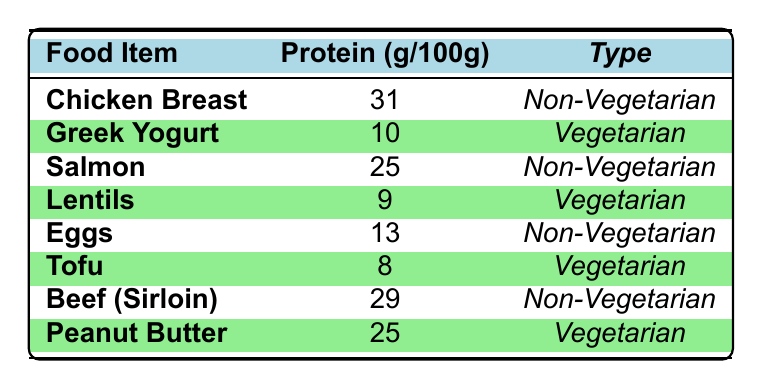What is the protein content of Chicken Breast? The protein content of Chicken Breast can be found in the table, where it is listed as 31 g per 100 g.
Answer: 31 g Which vegetarian food item has the highest protein content? In the table, the protein contents of vegetarian foods are listed. Greek Yogurt has the highest amount at 10 g per 100 g.
Answer: Greek Yogurt What is the protein difference between Beef (Sirloin) and Eggs? According to the table, Beef (Sirloin) has 29 g of protein per 100 g and Eggs have 13 g. The difference is 29 - 13 = 16 g.
Answer: 16 g Is Peanut Butter a vegetarian food item? Checking the table, Peanut Butter is categorized under vegetarian foods.
Answer: Yes What is the average protein content of non-vegetarian foods listed? The protein contents for non-vegetarian foods are Chicken Breast (31 g), Salmon (25 g), Eggs (13 g), Pork Tenderloin (26 g), and Beef (Sirloin) (29 g). Adding these: 31 + 25 + 13 + 26 + 29 = 124 g. There are 5 data points, so the average is 124 / 5 = 24.8 g.
Answer: 24.8 g How many vegetarian food items contain more than 8 g of protein? According to the table, the vegetarian items with more than 8 g of protein are Greek Yogurt (10 g), Cottage Cheese (11 g), and Peanut Butter (25 g). Therefore, there are 3 items.
Answer: 3 What is the total protein content of all vegetarian items combined? The protein contents for vegetarian foods are Greek Yogurt (10 g), Cottage Cheese (11 g), Lentils (9 g), Quinoa (4 g), Tofu (8 g), Chickpeas (9 g), and Peanut Butter (25 g). Adding these gives 10 + 11 + 9 + 4 + 8 + 9 + 25 = 76 g of protein.
Answer: 76 g Which non-vegetarian food has the lowest protein content? Referring to the table, Eggs have the lowest protein content among non-vegetarian foods, listed at 13 g per 100 g.
Answer: Eggs What is the total protein content of Chicken Breast and Pork Tenderloin? Chicken Breast has 31 g and Pork Tenderloin has 26 g in the table. Adding these gives 31 + 26 = 57 g.
Answer: 57 g Are there more non-vegetarian food items with protein content above 20 g than vegetarian items? The non-vegetarian items with protein above 20 g are Chicken Breast (31 g), Salmon (25 g), Pork Tenderloin (26 g), and Beef (Sirloin) (29 g), totaling 4 items. Vegetarian items above 20 g include only Peanut Butter (25 g). Therefore, non-vegetarian items are greater.
Answer: Yes 